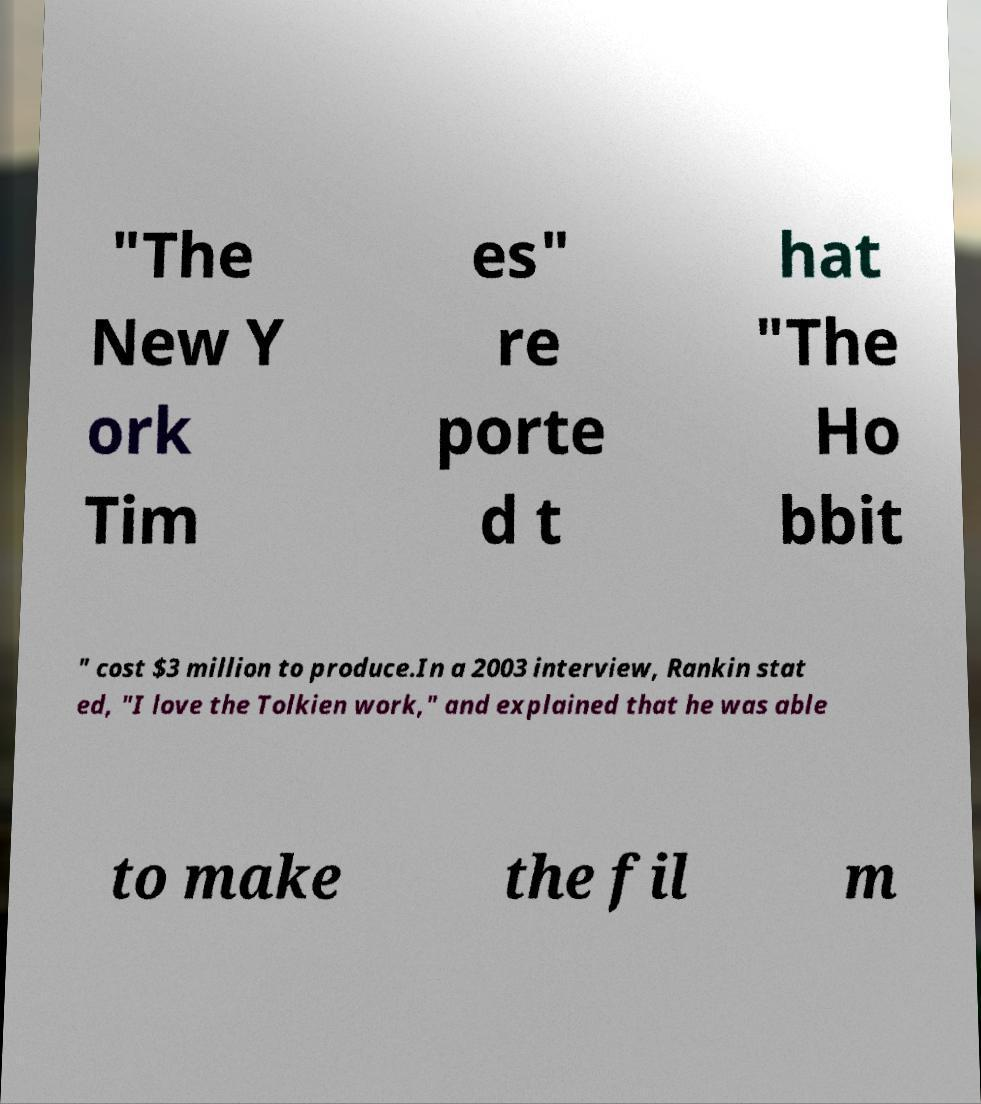There's text embedded in this image that I need extracted. Can you transcribe it verbatim? "The New Y ork Tim es" re porte d t hat "The Ho bbit " cost $3 million to produce.In a 2003 interview, Rankin stat ed, "I love the Tolkien work," and explained that he was able to make the fil m 